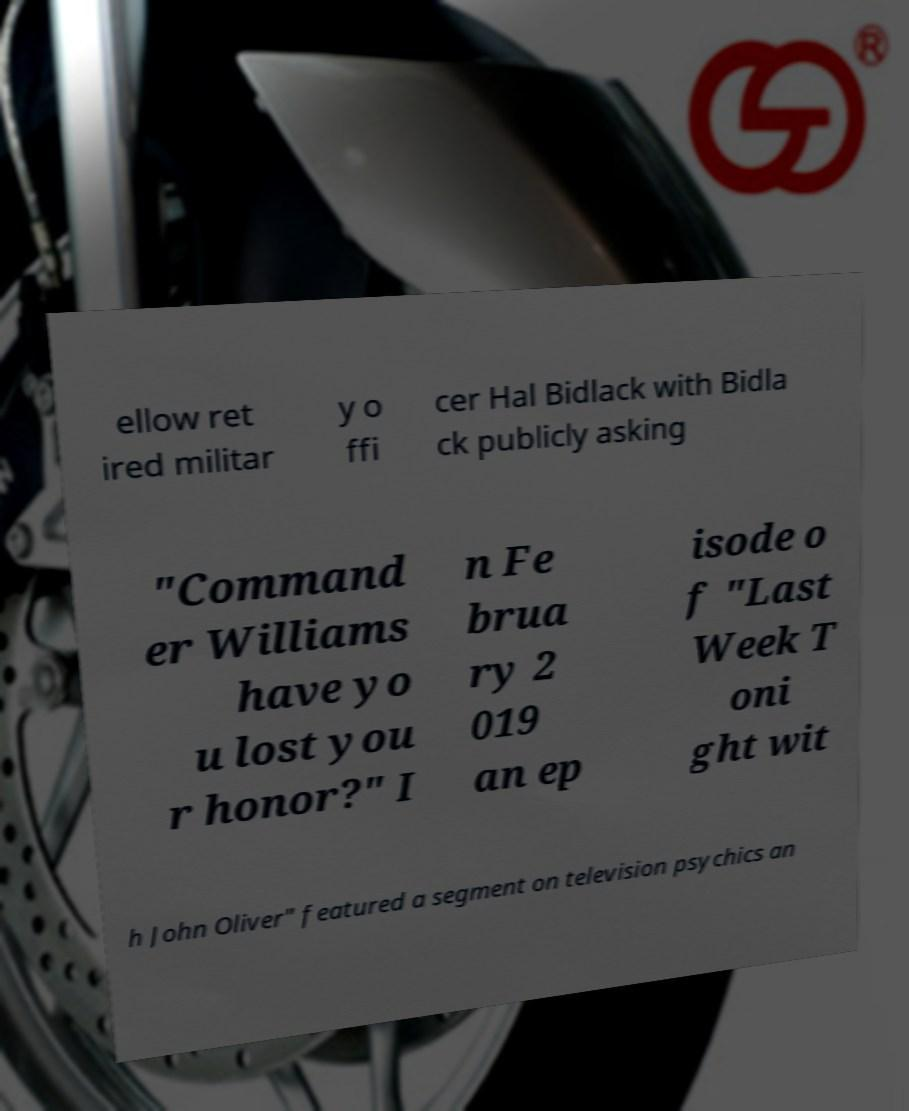Please read and relay the text visible in this image. What does it say? ellow ret ired militar y o ffi cer Hal Bidlack with Bidla ck publicly asking "Command er Williams have yo u lost you r honor?" I n Fe brua ry 2 019 an ep isode o f "Last Week T oni ght wit h John Oliver" featured a segment on television psychics an 